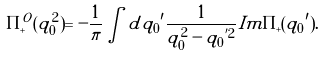<formula> <loc_0><loc_0><loc_500><loc_500>\Pi _ { + } ^ { O } ( q _ { 0 } ^ { 2 } ) = - \frac { 1 } { \pi } \int d { q _ { 0 } } ^ { \prime } \frac { 1 } { q _ { 0 } ^ { 2 } - { q _ { 0 } } ^ { ^ { \prime } 2 } } I m \Pi _ { + } ( { q _ { 0 } } ^ { \prime } ) .</formula> 